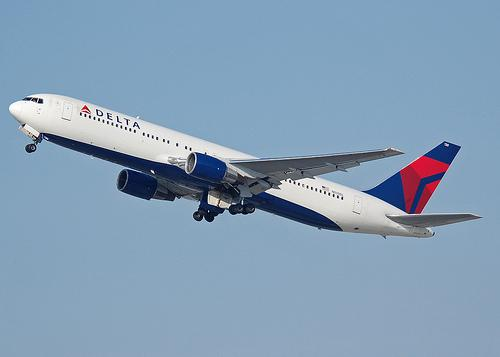Question: what is the main subject of photo?
Choices:
A. Air plane.
B. A cloud.
C. The sky.
D. The sun.
Answer with the letter. Answer: A Question: what color is the plane?
Choices:
A. Black.
B. Grey.
C. White.
D. Blue.
Answer with the letter. Answer: C Question: who can be seen in picture?
Choices:
A. A man.
B. A woman.
C. The boy.
D. No one.
Answer with the letter. Answer: D Question: what is written on side of plane?
Choices:
A. Pan-Am.
B. Delta.
C. United.
D. Virgin Air.
Answer with the letter. Answer: B Question: when was photo taken?
Choices:
A. At midnight.
B. During the day.
C. Just before sunrise.
D. Just after sunset.
Answer with the letter. Answer: B 